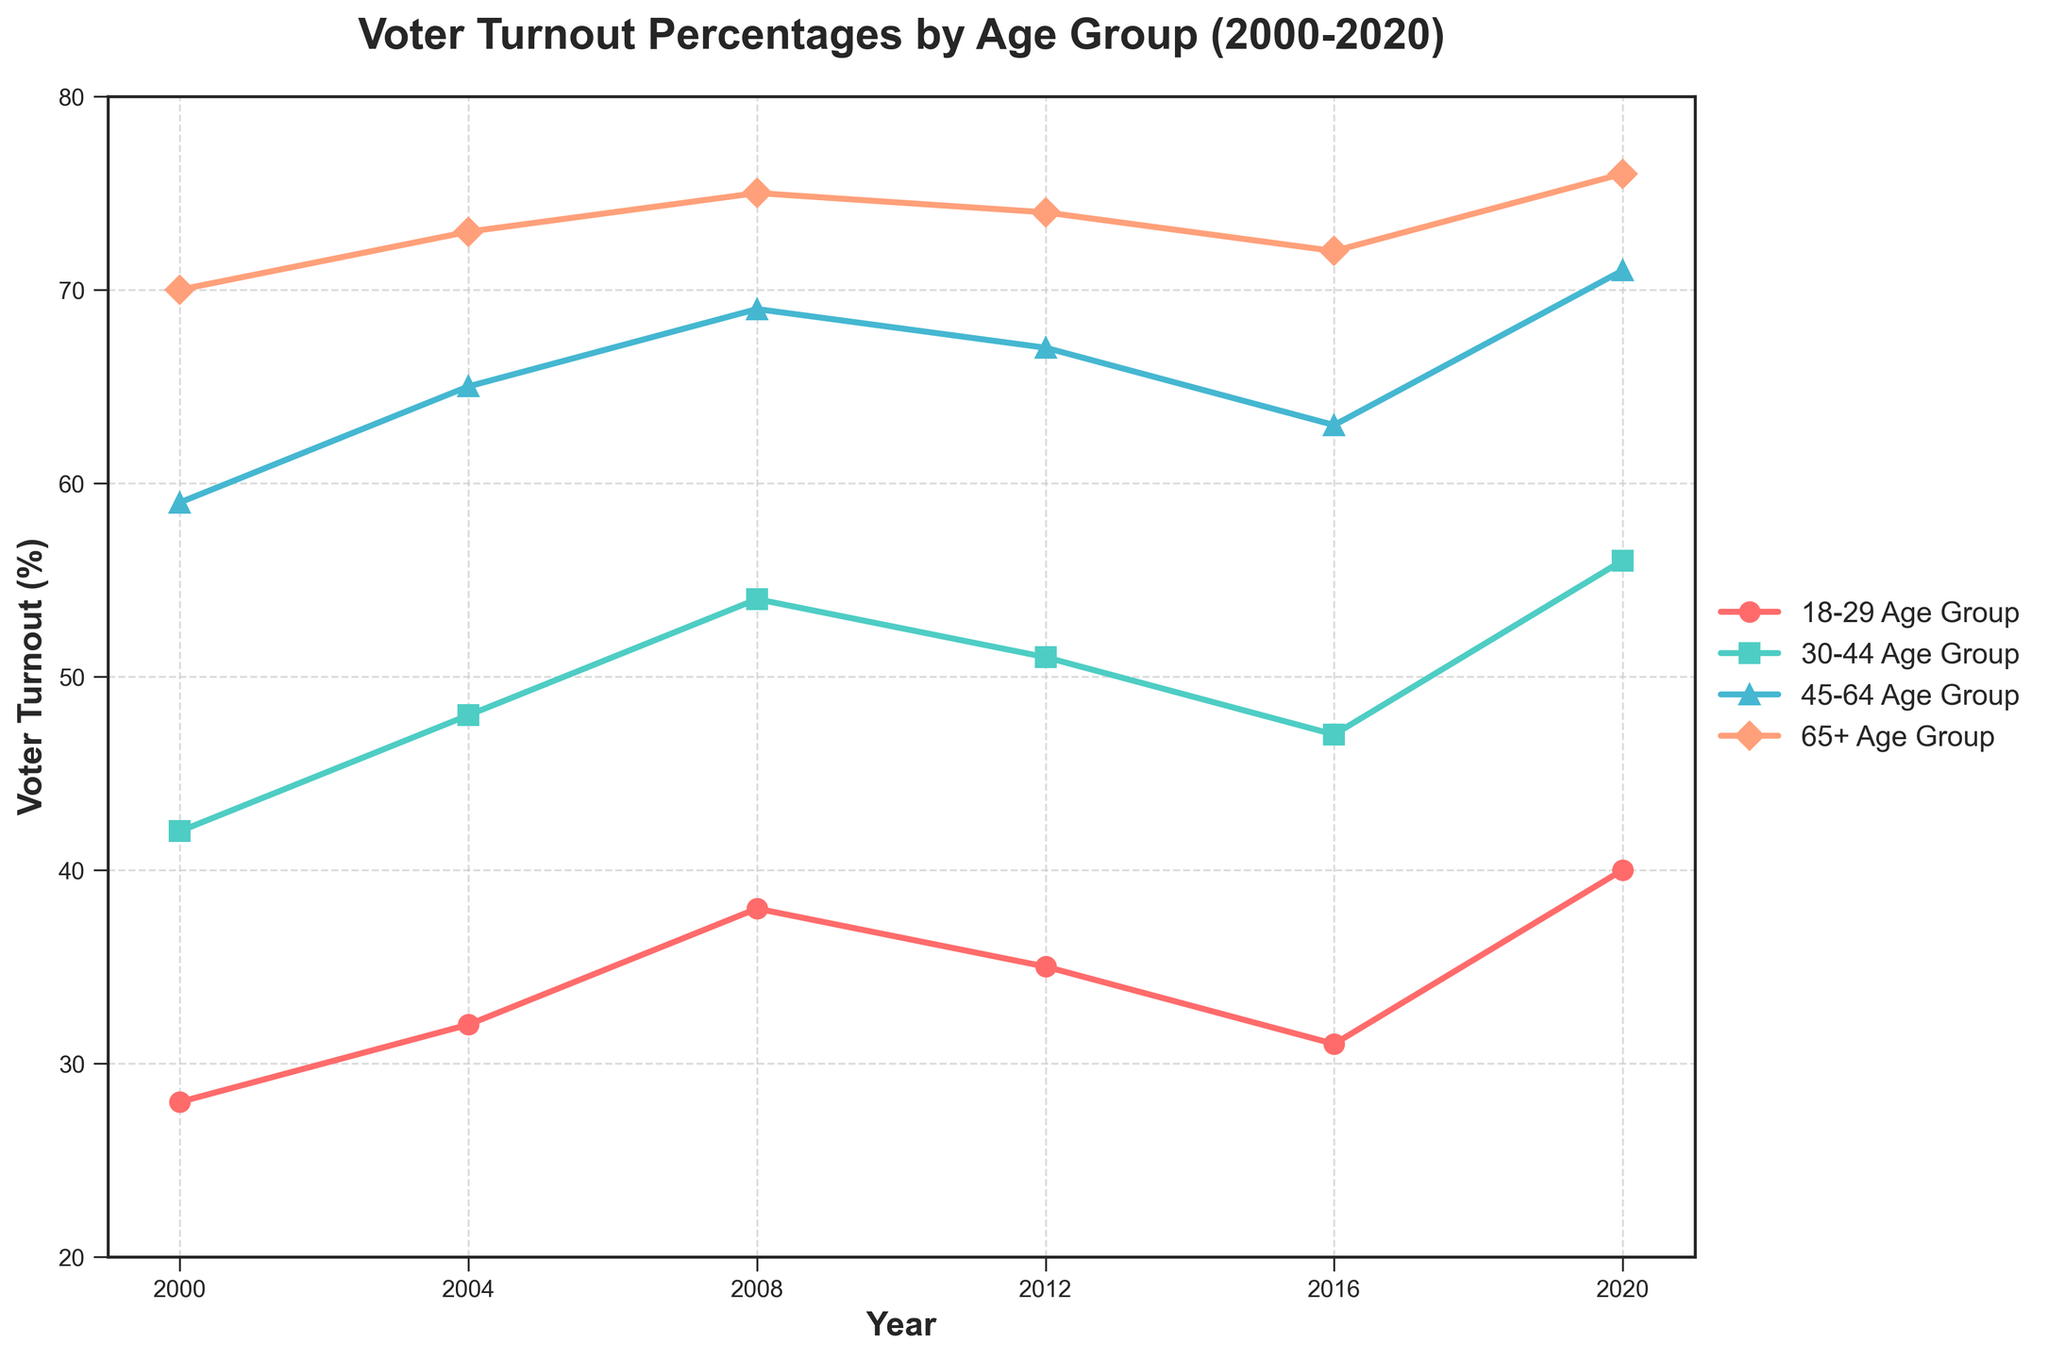How did the voter turnout percentage for the 18-29 age group change from 2000 to 2020? To find the change, look at the voter turnout percentage for the 18-29 age group in 2000 and 2020. In 2000, it was 28%, and in 2020, it was 40%. Subtract the 2000 value from the 2020 value: 40 - 28 = 12%.
Answer: 12% Which age group consistently had the highest voter turnout percentages from 2000 to 2020? Look at the voter turnout percentages for all the age groups across the years and identify the one with the highest values consistently. The 65+ Age Group had the highest percentages in all the years ranging from 70% to 76%.
Answer: 65+ Age Group By how much did the voter turnout percentage for middle-income individuals change from 2000 to 2020? Refer to the voter turnout percentages for middle-income individuals in 2000 and 2020. In 2000, it was 52%, and in 2020, it was 63%. The change is obtained by subtracting the 2000 value from the 2020 value: 63 - 52 = 11%.
Answer: 11% Compare the voter turnout trends between the Black demographic group and the Hispanic demographic group from 2000 to 2020. Which group saw a larger increase? Check the percentage increase for both groups from 2000 to 2020. For the Black demographic, it increased from 50% to 62% (62 - 50 = 12%). For the Hispanic demographic, it increased from 32% to 45% (45 - 32 = 13%).
Answer: Hispanic Which group had the lowest voter turnout percentage in 2016? Look at the voter turnout percentages for all groups in 2016 and identify the group with the lowest value. The 18-29 Age Group had the lowest voter turnout at 31%.
Answer: 18-29 Age Group What is the average voter turnout percentage for the 30-44 age group over the period from 2000 to 2020? Calculate the average by summing the turnout percentages for the 30-44 age group over the years and dividing by the number of years. (42+48+54+51+47+56)/6 = 298/6 ≈ 49.67%.
Answer: 49.67% How do voter turnout percentages in 2020 for the high-income group compare to the 18-29 age group? Refer to the voter turnouts in 2020 for the high-income group and the 18-29 age group. The high-income group had 77%, and the 18-29 age group had 40%. The high-income group's turnout is significantly higher by 77 - 40 = 37%.
Answer: 37% Which demographic saw the highest increase in voter turnout percentage from 2016 to 2020? Calculate the increase for each demographic by subtracting the 2016 value from the 2020 value. The Hispanic group saw an increase from 38% to 45%, an increase of 45 - 38 = 7%, the largest among them.
Answer: Hispanic What was the approximate median voter turnout percentage across all age groups in the year 2008? List the voter turnout percentages for all age groups in 2008: 38%, 54%, 69%, 75%. The median is the average of the two middle numbers when the data is sorted: (54+69)/2 = 61.5%.
Answer: 61.5% How did the voter turnout of the Asian demographic change from 2004 to 2012? Look at the turnout percentages for the Asian demographic in 2004 (45%) and 2012 (48%). Subtract the 2004 value from the 2012 value: 48 - 45 = 3%.
Answer: 3% 